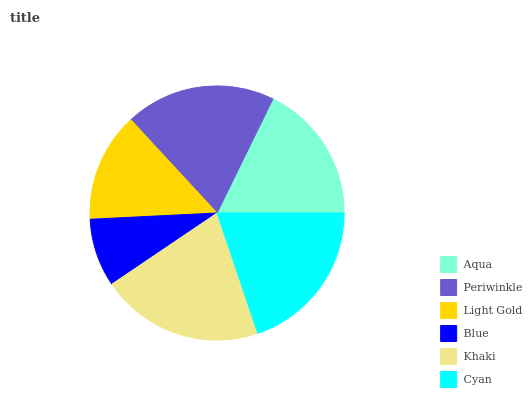Is Blue the minimum?
Answer yes or no. Yes. Is Khaki the maximum?
Answer yes or no. Yes. Is Periwinkle the minimum?
Answer yes or no. No. Is Periwinkle the maximum?
Answer yes or no. No. Is Periwinkle greater than Aqua?
Answer yes or no. Yes. Is Aqua less than Periwinkle?
Answer yes or no. Yes. Is Aqua greater than Periwinkle?
Answer yes or no. No. Is Periwinkle less than Aqua?
Answer yes or no. No. Is Periwinkle the high median?
Answer yes or no. Yes. Is Aqua the low median?
Answer yes or no. Yes. Is Cyan the high median?
Answer yes or no. No. Is Light Gold the low median?
Answer yes or no. No. 